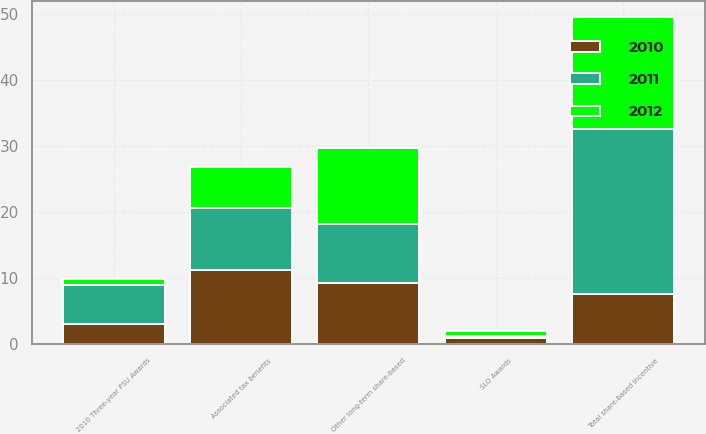Convert chart. <chart><loc_0><loc_0><loc_500><loc_500><stacked_bar_chart><ecel><fcel>2010 Three-year PSU Awards<fcel>SLO Awards<fcel>Other long-term share-based<fcel>Total share-based incentive<fcel>Associated tax benefits<nl><fcel>2012<fcel>0.9<fcel>0.7<fcel>11.5<fcel>16.9<fcel>6.2<nl><fcel>2011<fcel>6<fcel>0.3<fcel>9<fcel>25<fcel>9.3<nl><fcel>2010<fcel>3<fcel>1<fcel>9.2<fcel>7.6<fcel>11.3<nl></chart> 